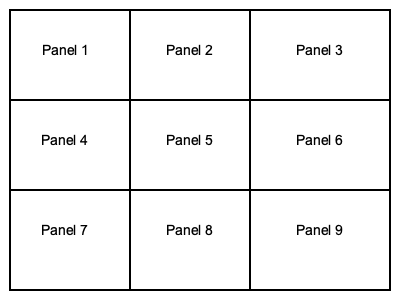In the context of storyboarding for film, what is the primary purpose of using a simple 3x3 panel layout as shown in the image? 1. Visual organization: The 3x3 panel layout provides a clear, organized structure for presenting key scenes or shots in a sequence.

2. Narrative flow: Reading from left to right and top to bottom, this layout naturally guides the viewer through the story's progression.

3. Pacing: Each panel represents a distinct moment or shot, allowing filmmakers to control the story's rhythm and timing visually.

4. Shot variety: The grid encourages filmmakers to think about different types of shots (e.g., close-ups, wide shots) to create visual interest.

5. Composition practice: The limited space in each panel forces the artist to focus on essential elements, improving compositional skills.

6. Establishing continuity: Adjacent panels help visualize how scenes transition and maintain visual coherence throughout the sequence.

7. Efficient communication: This simple layout allows filmmakers to quickly convey their vision to crew members and stakeholders.

8. Flexibility: The 3x3 grid can be easily modified or expanded to accommodate more complex sequences if needed.

9. Time management: Having a predefined number of panels helps in estimating the duration of scenes and the overall project.

The primary purpose of this layout is to provide a clear, structured approach to visualizing and planning a film's key moments, enhancing storytelling and communication within the production team.
Answer: To visually organize and plan key film moments, enhancing storytelling and communication. 